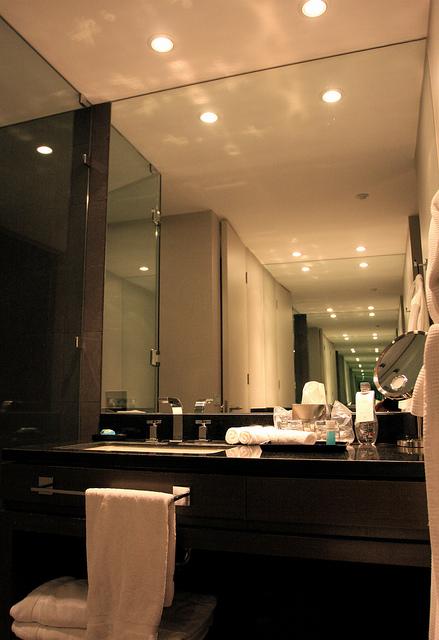Are the folded towels clean?
Be succinct. Yes. Whose house is this?
Answer briefly. Bathroom. What type of room is this?
Be succinct. Bathroom. 